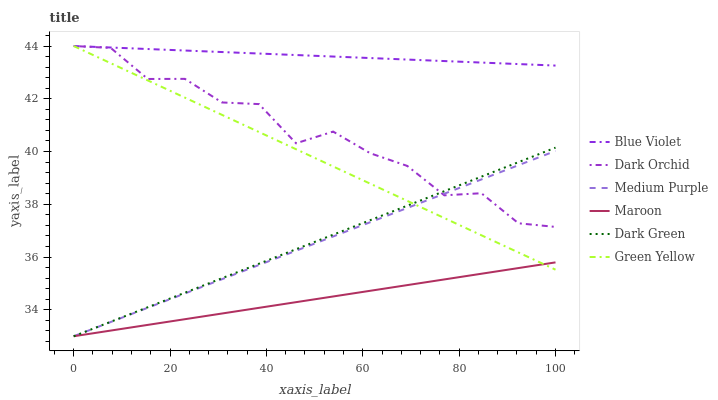Does Medium Purple have the minimum area under the curve?
Answer yes or no. No. Does Medium Purple have the maximum area under the curve?
Answer yes or no. No. Is Dark Orchid the smoothest?
Answer yes or no. No. Is Medium Purple the roughest?
Answer yes or no. No. Does Dark Orchid have the lowest value?
Answer yes or no. No. Does Medium Purple have the highest value?
Answer yes or no. No. Is Maroon less than Blue Violet?
Answer yes or no. Yes. Is Dark Orchid greater than Maroon?
Answer yes or no. Yes. Does Maroon intersect Blue Violet?
Answer yes or no. No. 